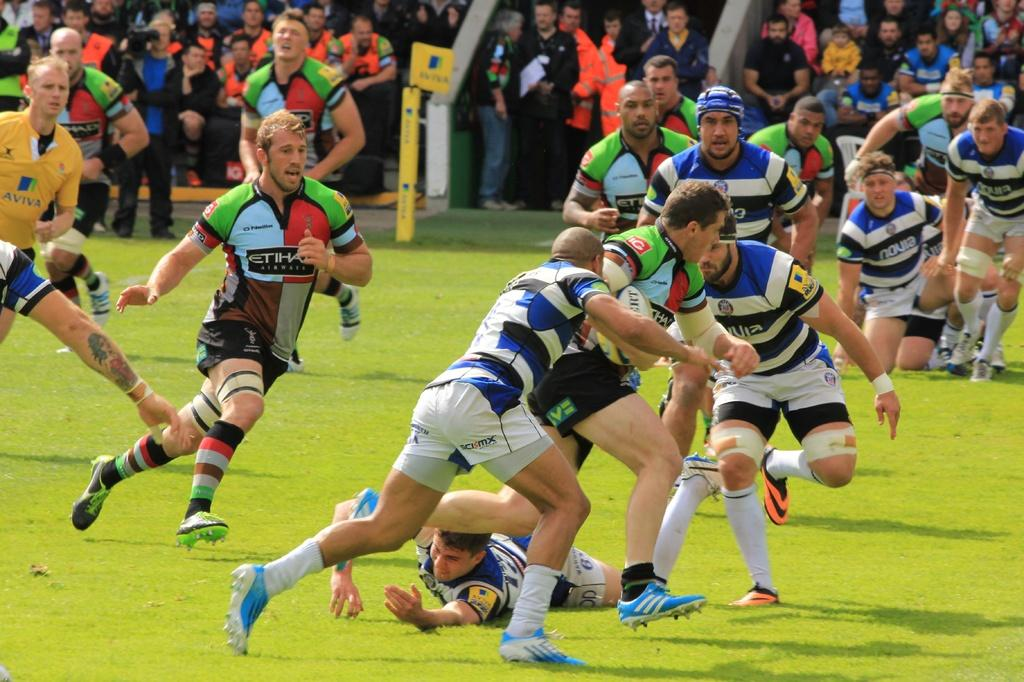<image>
Render a clear and concise summary of the photo. Two soccer teams, Etihad and Novia, are competing with the stands full of people. 